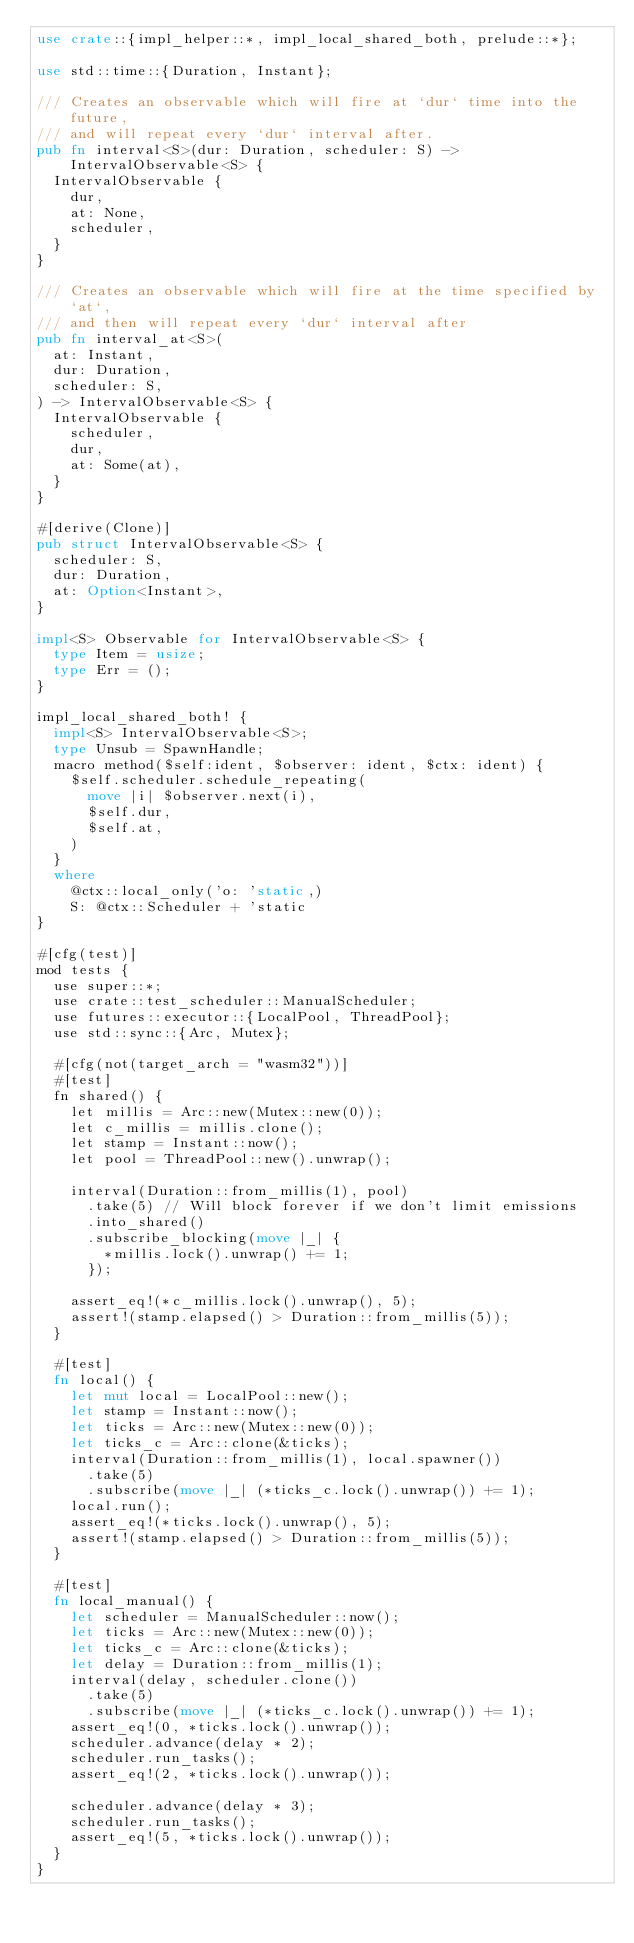Convert code to text. <code><loc_0><loc_0><loc_500><loc_500><_Rust_>use crate::{impl_helper::*, impl_local_shared_both, prelude::*};

use std::time::{Duration, Instant};

/// Creates an observable which will fire at `dur` time into the future,
/// and will repeat every `dur` interval after.
pub fn interval<S>(dur: Duration, scheduler: S) -> IntervalObservable<S> {
  IntervalObservable {
    dur,
    at: None,
    scheduler,
  }
}

/// Creates an observable which will fire at the time specified by `at`,
/// and then will repeat every `dur` interval after
pub fn interval_at<S>(
  at: Instant,
  dur: Duration,
  scheduler: S,
) -> IntervalObservable<S> {
  IntervalObservable {
    scheduler,
    dur,
    at: Some(at),
  }
}

#[derive(Clone)]
pub struct IntervalObservable<S> {
  scheduler: S,
  dur: Duration,
  at: Option<Instant>,
}

impl<S> Observable for IntervalObservable<S> {
  type Item = usize;
  type Err = ();
}

impl_local_shared_both! {
  impl<S> IntervalObservable<S>;
  type Unsub = SpawnHandle;
  macro method($self:ident, $observer: ident, $ctx: ident) {
    $self.scheduler.schedule_repeating(
      move |i| $observer.next(i),
      $self.dur,
      $self.at,
    )
  }
  where
    @ctx::local_only('o: 'static,)
    S: @ctx::Scheduler + 'static
}

#[cfg(test)]
mod tests {
  use super::*;
  use crate::test_scheduler::ManualScheduler;
  use futures::executor::{LocalPool, ThreadPool};
  use std::sync::{Arc, Mutex};

  #[cfg(not(target_arch = "wasm32"))]
  #[test]
  fn shared() {
    let millis = Arc::new(Mutex::new(0));
    let c_millis = millis.clone();
    let stamp = Instant::now();
    let pool = ThreadPool::new().unwrap();

    interval(Duration::from_millis(1), pool)
      .take(5) // Will block forever if we don't limit emissions
      .into_shared()
      .subscribe_blocking(move |_| {
        *millis.lock().unwrap() += 1;
      });

    assert_eq!(*c_millis.lock().unwrap(), 5);
    assert!(stamp.elapsed() > Duration::from_millis(5));
  }

  #[test]
  fn local() {
    let mut local = LocalPool::new();
    let stamp = Instant::now();
    let ticks = Arc::new(Mutex::new(0));
    let ticks_c = Arc::clone(&ticks);
    interval(Duration::from_millis(1), local.spawner())
      .take(5)
      .subscribe(move |_| (*ticks_c.lock().unwrap()) += 1);
    local.run();
    assert_eq!(*ticks.lock().unwrap(), 5);
    assert!(stamp.elapsed() > Duration::from_millis(5));
  }

  #[test]
  fn local_manual() {
    let scheduler = ManualScheduler::now();
    let ticks = Arc::new(Mutex::new(0));
    let ticks_c = Arc::clone(&ticks);
    let delay = Duration::from_millis(1);
    interval(delay, scheduler.clone())
      .take(5)
      .subscribe(move |_| (*ticks_c.lock().unwrap()) += 1);
    assert_eq!(0, *ticks.lock().unwrap());
    scheduler.advance(delay * 2);
    scheduler.run_tasks();
    assert_eq!(2, *ticks.lock().unwrap());

    scheduler.advance(delay * 3);
    scheduler.run_tasks();
    assert_eq!(5, *ticks.lock().unwrap());
  }
}
</code> 